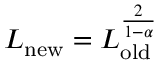Convert formula to latex. <formula><loc_0><loc_0><loc_500><loc_500>L _ { n e w } = L _ { o l d } ^ { \frac { 2 } { 1 - \alpha } }</formula> 